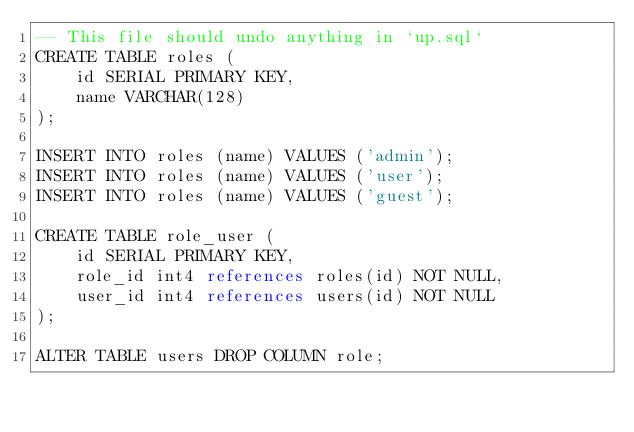Convert code to text. <code><loc_0><loc_0><loc_500><loc_500><_SQL_>-- This file should undo anything in `up.sql`
CREATE TABLE roles (
    id SERIAL PRIMARY KEY,
    name VARCHAR(128)
);

INSERT INTO roles (name) VALUES ('admin');
INSERT INTO roles (name) VALUES ('user');
INSERT INTO roles (name) VALUES ('guest');

CREATE TABLE role_user (
    id SERIAL PRIMARY KEY,
    role_id int4 references roles(id) NOT NULL,
    user_id int4 references users(id) NOT NULL
);

ALTER TABLE users DROP COLUMN role;
</code> 